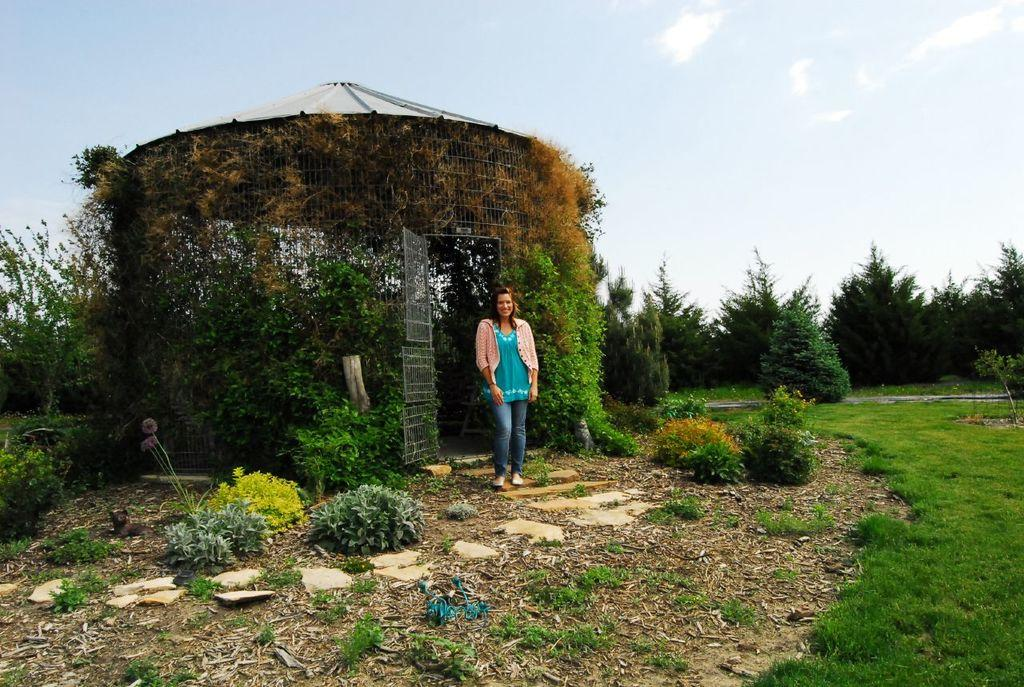What type of vegetation can be seen in the image? There are trees, grass, and plants in the image. What is the woman standing on in the image? The woman is standing on grass in the image. What is visible at the top of the image? The sky is visible at the top of the image. What type of machine is being used by the woman in the image? There is no machine visible in the image; the woman is simply standing. What scene is depicted in the image? The image depicts a woman standing in a natural environment with trees, grass, and plants. 